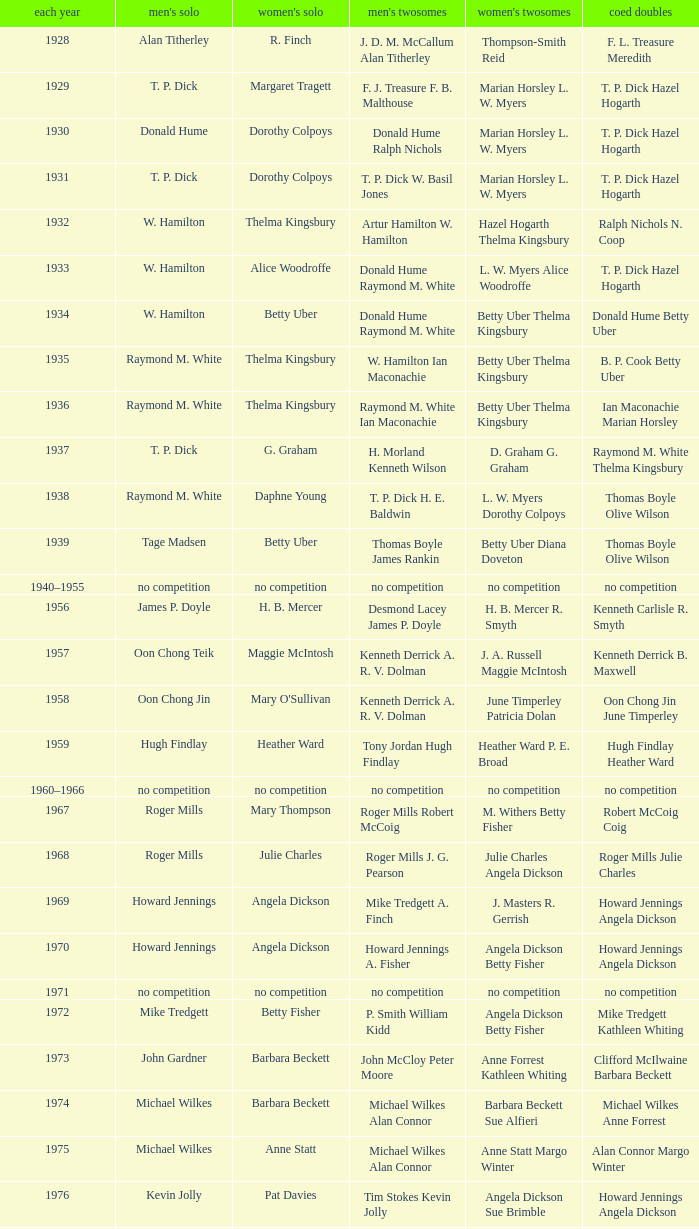Who won the Women's doubles in the year that David Eddy Eddy Sutton won the Men's doubles, and that David Eddy won the Men's singles? Anne Statt Jane Webster. 